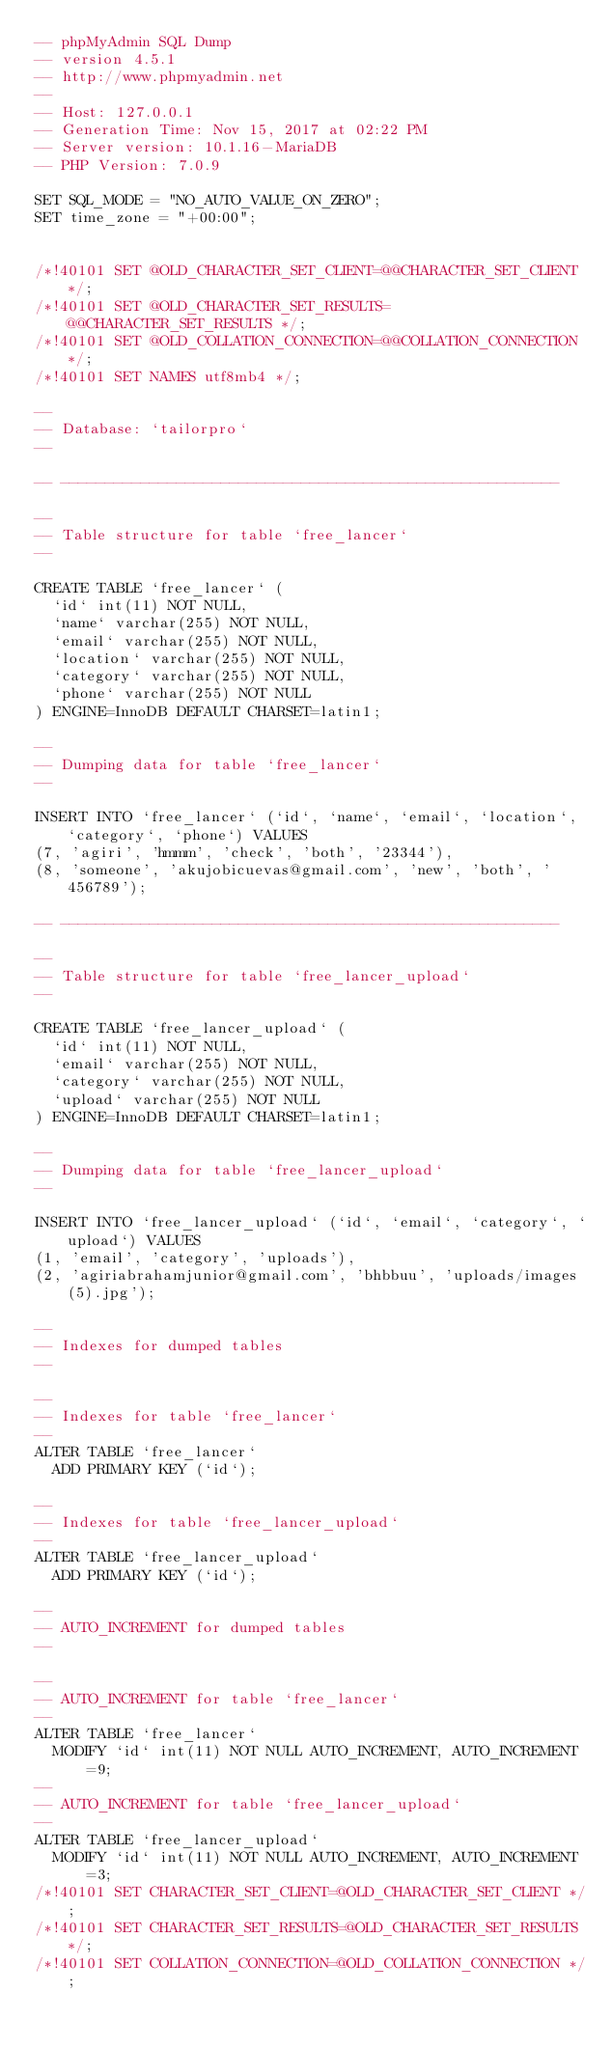Convert code to text. <code><loc_0><loc_0><loc_500><loc_500><_SQL_>-- phpMyAdmin SQL Dump
-- version 4.5.1
-- http://www.phpmyadmin.net
--
-- Host: 127.0.0.1
-- Generation Time: Nov 15, 2017 at 02:22 PM
-- Server version: 10.1.16-MariaDB
-- PHP Version: 7.0.9

SET SQL_MODE = "NO_AUTO_VALUE_ON_ZERO";
SET time_zone = "+00:00";


/*!40101 SET @OLD_CHARACTER_SET_CLIENT=@@CHARACTER_SET_CLIENT */;
/*!40101 SET @OLD_CHARACTER_SET_RESULTS=@@CHARACTER_SET_RESULTS */;
/*!40101 SET @OLD_COLLATION_CONNECTION=@@COLLATION_CONNECTION */;
/*!40101 SET NAMES utf8mb4 */;

--
-- Database: `tailorpro`
--

-- --------------------------------------------------------

--
-- Table structure for table `free_lancer`
--

CREATE TABLE `free_lancer` (
  `id` int(11) NOT NULL,
  `name` varchar(255) NOT NULL,
  `email` varchar(255) NOT NULL,
  `location` varchar(255) NOT NULL,
  `category` varchar(255) NOT NULL,
  `phone` varchar(255) NOT NULL
) ENGINE=InnoDB DEFAULT CHARSET=latin1;

--
-- Dumping data for table `free_lancer`
--

INSERT INTO `free_lancer` (`id`, `name`, `email`, `location`, `category`, `phone`) VALUES
(7, 'agiri', 'hmmm', 'check', 'both', '23344'),
(8, 'someone', 'akujobicuevas@gmail.com', 'new', 'both', '456789');

-- --------------------------------------------------------

--
-- Table structure for table `free_lancer_upload`
--

CREATE TABLE `free_lancer_upload` (
  `id` int(11) NOT NULL,
  `email` varchar(255) NOT NULL,
  `category` varchar(255) NOT NULL,
  `upload` varchar(255) NOT NULL
) ENGINE=InnoDB DEFAULT CHARSET=latin1;

--
-- Dumping data for table `free_lancer_upload`
--

INSERT INTO `free_lancer_upload` (`id`, `email`, `category`, `upload`) VALUES
(1, 'email', 'category', 'uploads'),
(2, 'agiriabrahamjunior@gmail.com', 'bhbbuu', 'uploads/images (5).jpg');

--
-- Indexes for dumped tables
--

--
-- Indexes for table `free_lancer`
--
ALTER TABLE `free_lancer`
  ADD PRIMARY KEY (`id`);

--
-- Indexes for table `free_lancer_upload`
--
ALTER TABLE `free_lancer_upload`
  ADD PRIMARY KEY (`id`);

--
-- AUTO_INCREMENT for dumped tables
--

--
-- AUTO_INCREMENT for table `free_lancer`
--
ALTER TABLE `free_lancer`
  MODIFY `id` int(11) NOT NULL AUTO_INCREMENT, AUTO_INCREMENT=9;
--
-- AUTO_INCREMENT for table `free_lancer_upload`
--
ALTER TABLE `free_lancer_upload`
  MODIFY `id` int(11) NOT NULL AUTO_INCREMENT, AUTO_INCREMENT=3;
/*!40101 SET CHARACTER_SET_CLIENT=@OLD_CHARACTER_SET_CLIENT */;
/*!40101 SET CHARACTER_SET_RESULTS=@OLD_CHARACTER_SET_RESULTS */;
/*!40101 SET COLLATION_CONNECTION=@OLD_COLLATION_CONNECTION */;
</code> 